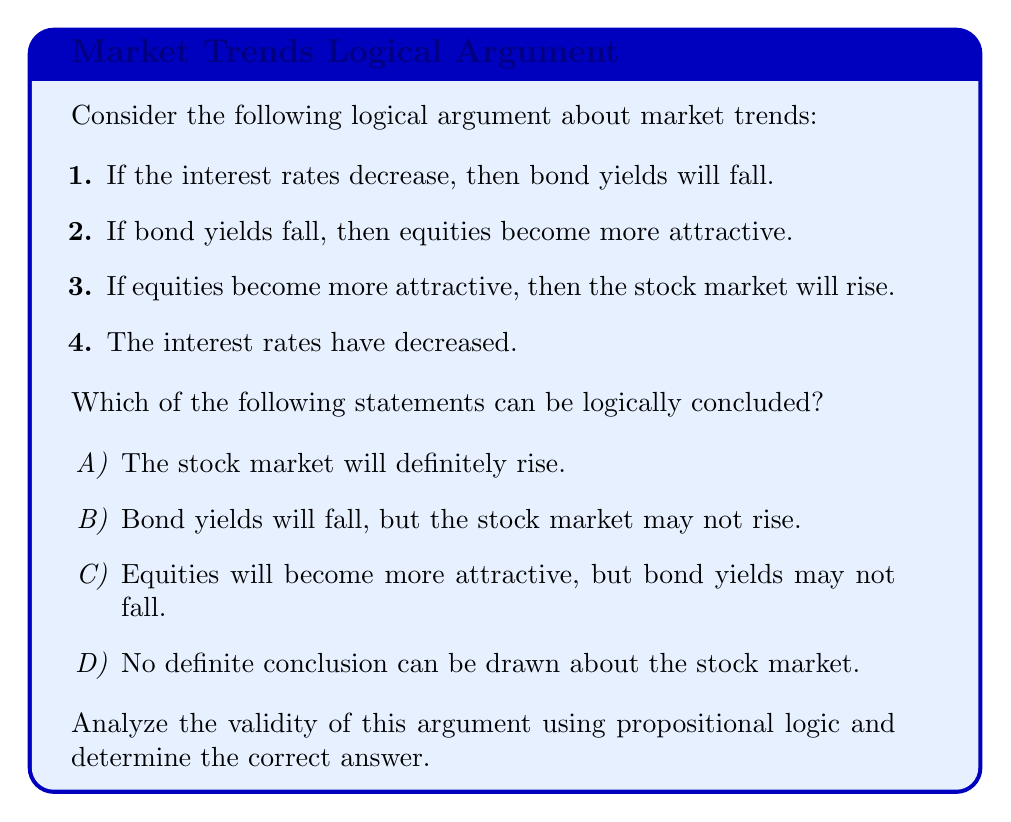What is the answer to this math problem? Let's approach this step-by-step using propositional logic:

1) First, let's define our propositions:
   $p$: Interest rates decrease
   $q$: Bond yields fall
   $r$: Equities become more attractive
   $s$: Stock market rises

2) Now, we can represent the given statements as logical implications:
   Statement 1: $p \rightarrow q$
   Statement 2: $q \rightarrow r$
   Statement 3: $r \rightarrow s$
   Statement 4: $p$ (given as true)

3) We can use the rule of modus ponens, which states that if we have $P \rightarrow Q$ and $P$ is true, then $Q$ must be true.

4) Applying modus ponens to statement 1 and 4:
   $p \rightarrow q$ and $p$ is true, therefore $q$ is true.

5) Now we know $q$ is true, we can apply modus ponens again with statement 2:
   $q \rightarrow r$ and $q$ is true, therefore $r$ is true.

6) Finally, we can apply modus ponens once more with statement 3:
   $r \rightarrow s$ and $r$ is true, therefore $s$ is true.

7) Following this chain of logic, we can conclude that if the premises are true, then the stock market will rise ($s$ is true).

Therefore, the correct answer is A) The stock market will definitely rise.

This argument is valid because the conclusion follows logically from the premises. However, it's important to note that in real-world scenarios, market behavior is influenced by many factors and may not always follow such straightforward logic.
Answer: A 